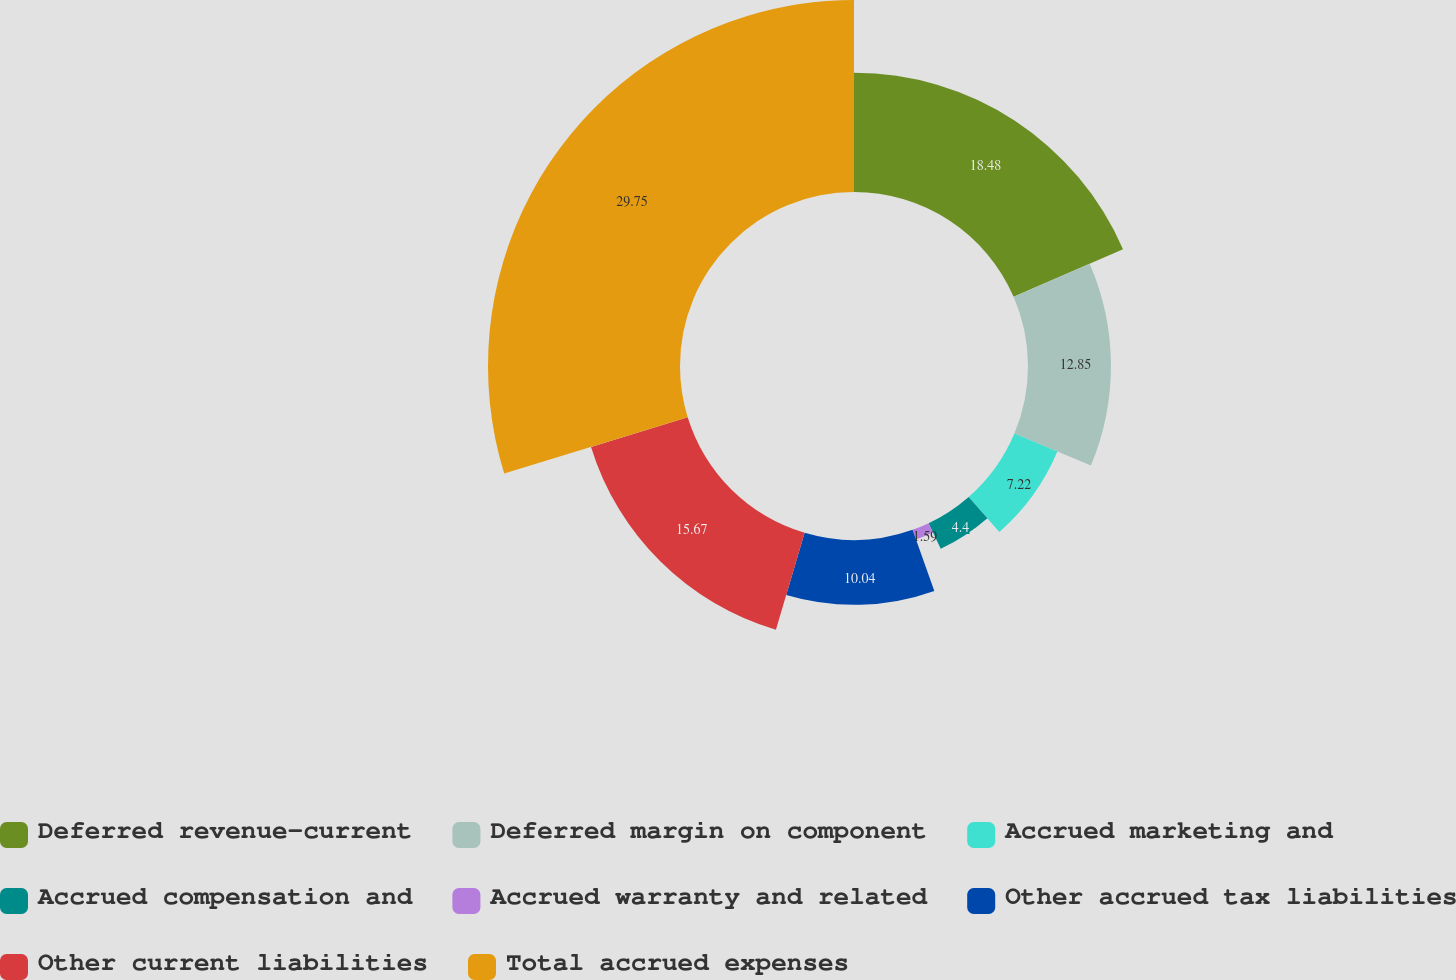<chart> <loc_0><loc_0><loc_500><loc_500><pie_chart><fcel>Deferred revenue-current<fcel>Deferred margin on component<fcel>Accrued marketing and<fcel>Accrued compensation and<fcel>Accrued warranty and related<fcel>Other accrued tax liabilities<fcel>Other current liabilities<fcel>Total accrued expenses<nl><fcel>18.48%<fcel>12.85%<fcel>7.22%<fcel>4.4%<fcel>1.59%<fcel>10.04%<fcel>15.67%<fcel>29.75%<nl></chart> 